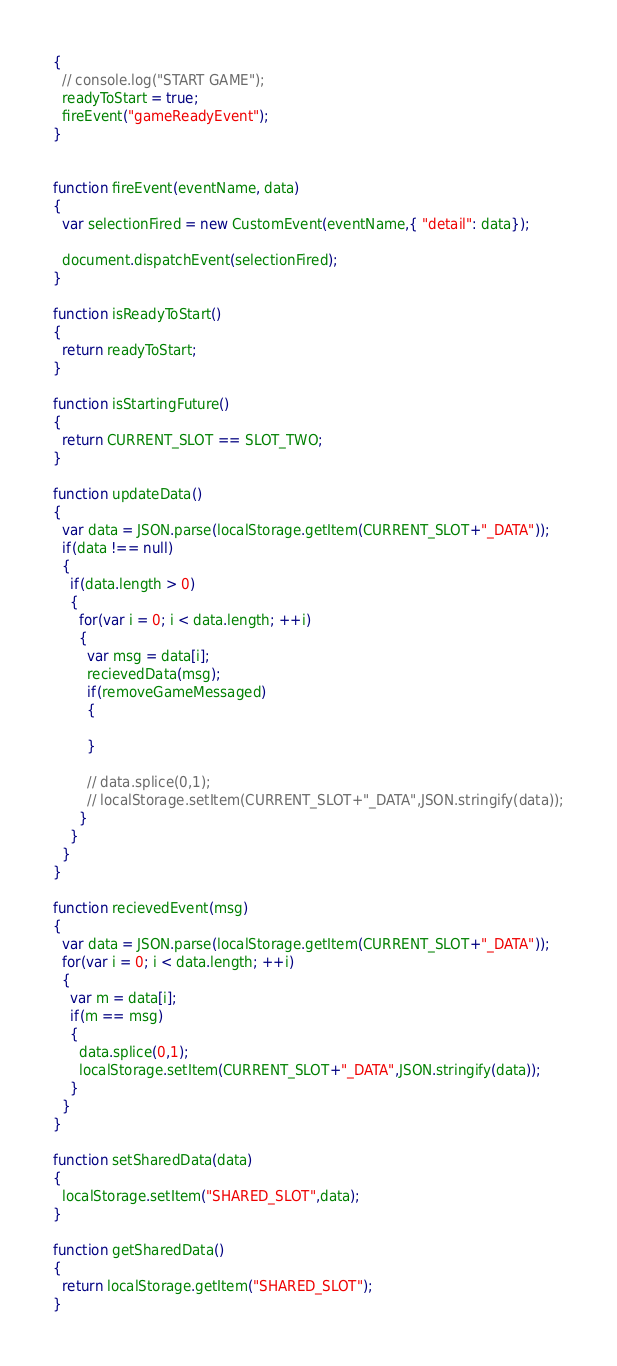<code> <loc_0><loc_0><loc_500><loc_500><_JavaScript_>{
  // console.log("START GAME");
  readyToStart = true;
  fireEvent("gameReadyEvent");
}


function fireEvent(eventName, data)
{
  var selectionFired = new CustomEvent(eventName,{ "detail": data});

  document.dispatchEvent(selectionFired);
}

function isReadyToStart()
{
  return readyToStart;
}

function isStartingFuture()
{
  return CURRENT_SLOT == SLOT_TWO;
}

function updateData()
{
  var data = JSON.parse(localStorage.getItem(CURRENT_SLOT+"_DATA"));
  if(data !== null)
  {
    if(data.length > 0)
    {
      for(var i = 0; i < data.length; ++i)
      {
        var msg = data[i];
        recievedData(msg);
        if(removeGameMessaged)
        {

        }

        // data.splice(0,1);
        // localStorage.setItem(CURRENT_SLOT+"_DATA",JSON.stringify(data));
      }
    }
  }
}

function recievedEvent(msg)
{
  var data = JSON.parse(localStorage.getItem(CURRENT_SLOT+"_DATA"));
  for(var i = 0; i < data.length; ++i)
  {
    var m = data[i];
    if(m == msg)
    {
      data.splice(0,1);
      localStorage.setItem(CURRENT_SLOT+"_DATA",JSON.stringify(data));
    }
  }
}

function setSharedData(data)
{
  localStorage.setItem("SHARED_SLOT",data);
}

function getSharedData()
{
  return localStorage.getItem("SHARED_SLOT");
}
</code> 